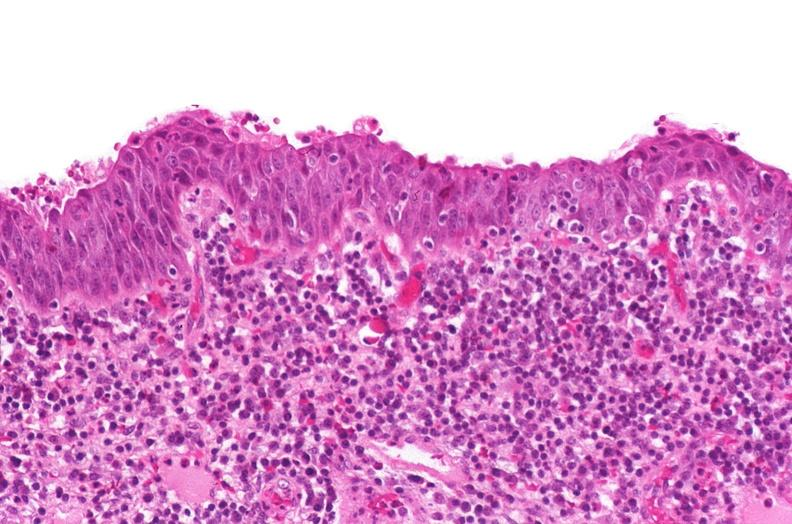where is this?
Answer the question using a single word or phrase. Urinary 